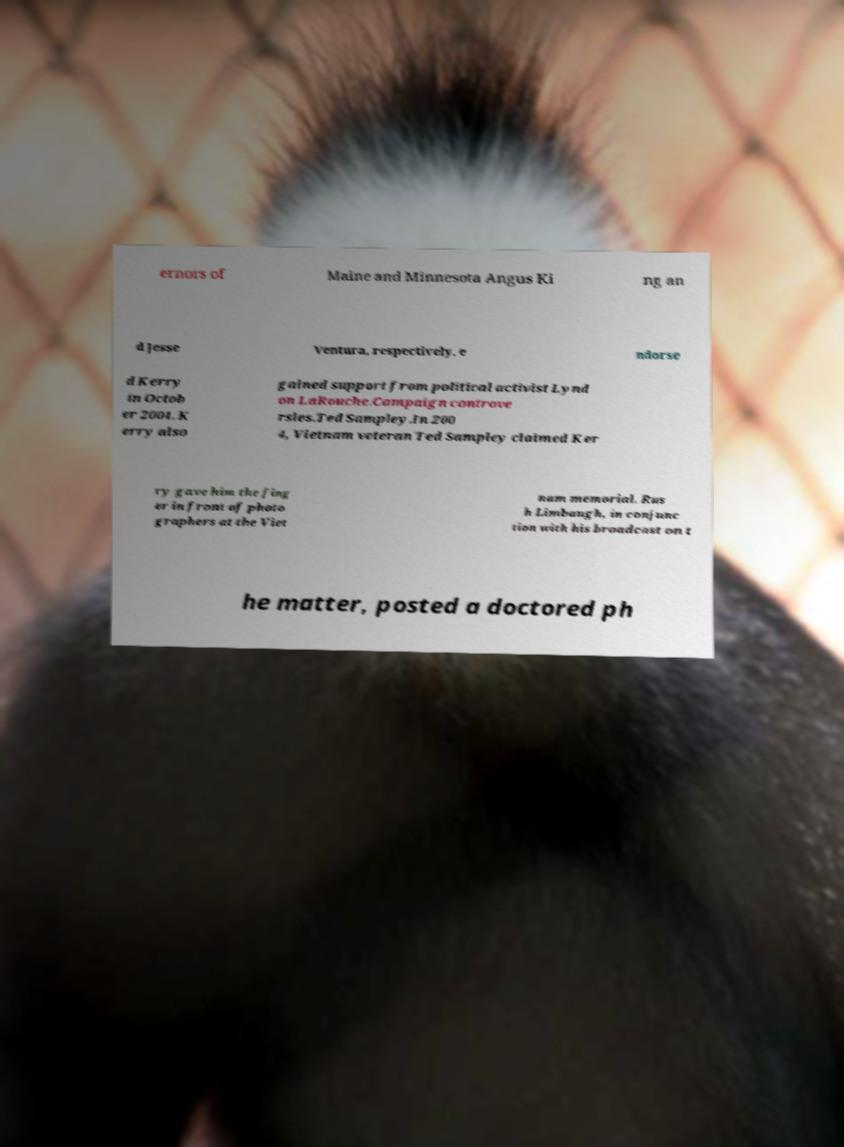Please read and relay the text visible in this image. What does it say? ernors of Maine and Minnesota Angus Ki ng an d Jesse Ventura, respectively, e ndorse d Kerry in Octob er 2004. K erry also gained support from political activist Lynd on LaRouche.Campaign controve rsies.Ted Sampley.In 200 4, Vietnam veteran Ted Sampley claimed Ker ry gave him the fing er in front of photo graphers at the Viet nam memorial. Rus h Limbaugh, in conjunc tion with his broadcast on t he matter, posted a doctored ph 